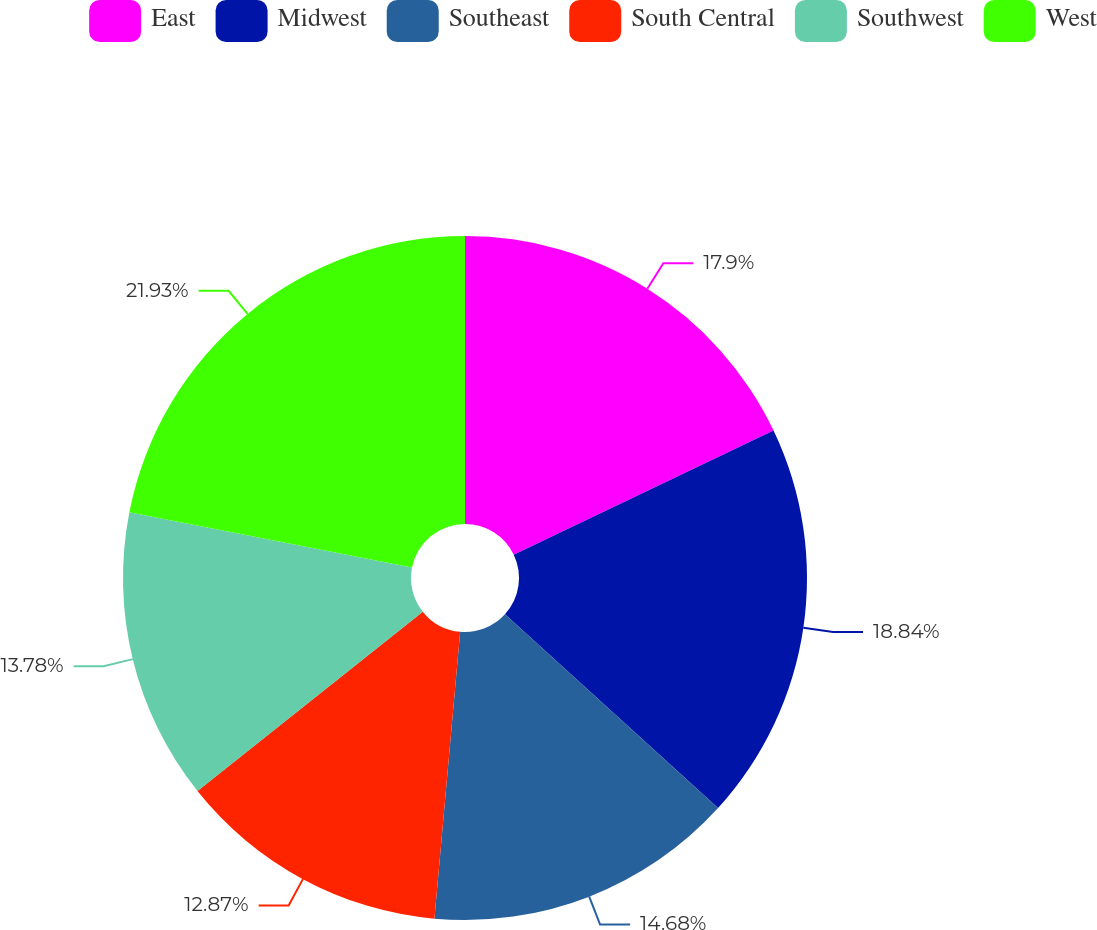Convert chart to OTSL. <chart><loc_0><loc_0><loc_500><loc_500><pie_chart><fcel>East<fcel>Midwest<fcel>Southeast<fcel>South Central<fcel>Southwest<fcel>West<nl><fcel>17.9%<fcel>18.84%<fcel>14.68%<fcel>12.87%<fcel>13.78%<fcel>21.92%<nl></chart> 